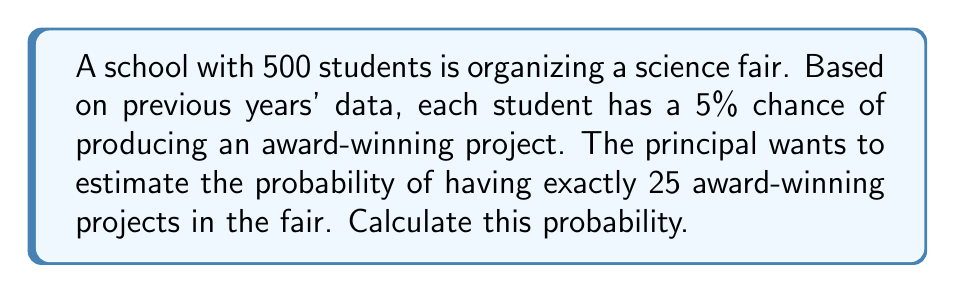Help me with this question. To solve this problem, we'll use the binomial probability distribution, as we have a fixed number of independent trials (500 students) with two possible outcomes for each (award-winning or not), and we're interested in a specific number of successes (25 award-winning projects).

The binomial probability formula is:

$$P(X = k) = \binom{n}{k} p^k (1-p)^{n-k}$$

Where:
$n$ = number of trials (500 students)
$k$ = number of successes (25 award-winning projects)
$p$ = probability of success on each trial (5% = 0.05)

Step 1: Calculate the binomial coefficient
$$\binom{500}{25} = \frac{500!}{25!(500-25)!} = \frac{500!}{25!475!}$$

Step 2: Substitute values into the binomial probability formula
$$P(X = 25) = \binom{500}{25} (0.05)^{25} (1-0.05)^{500-25}$$
$$= \binom{500}{25} (0.05)^{25} (0.95)^{475}$$

Step 3: Calculate the result
Using a calculator or computer (due to the large numbers involved):

$$P(X = 25) \approx 0.0584$$

This means there's about a 5.84% chance of having exactly 25 award-winning projects in the science fair.
Answer: $0.0584$ or $5.84\%$ 